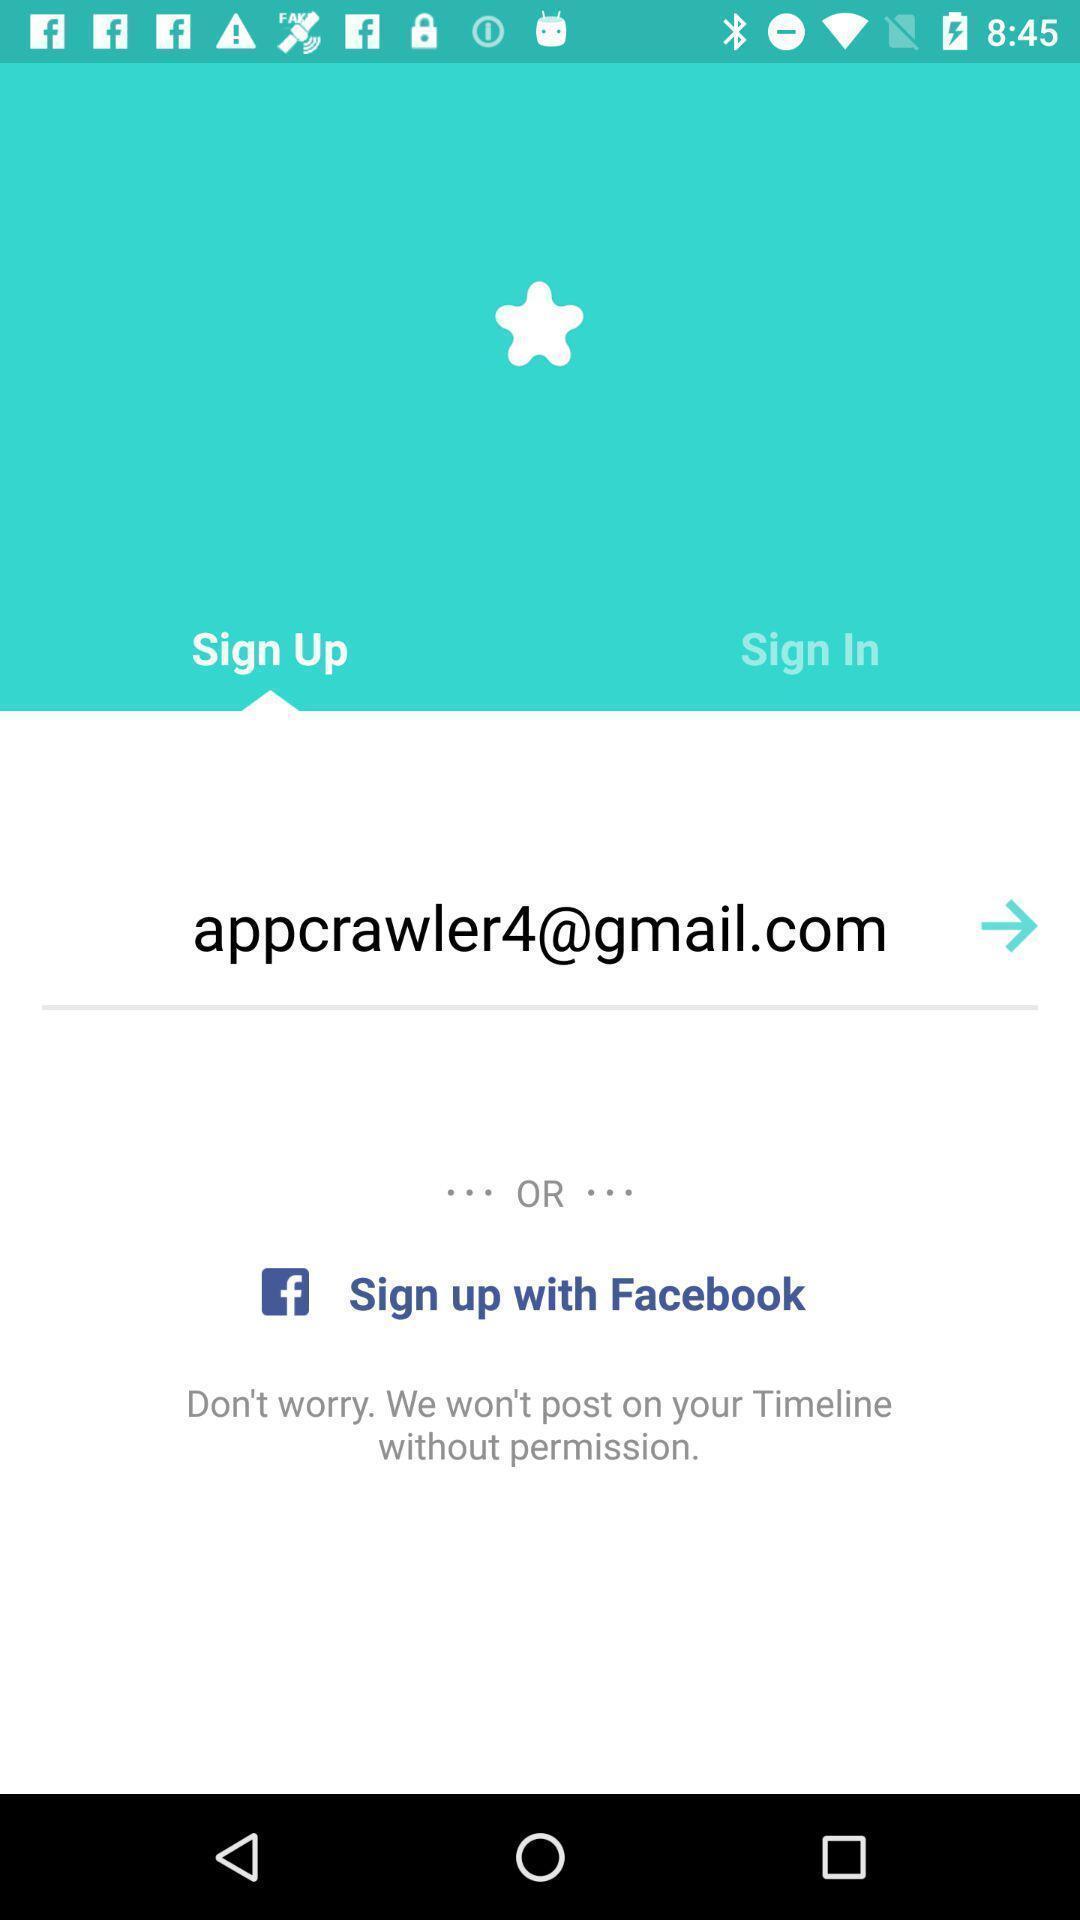Provide a description of this screenshot. Signup page with other options in adult app. 